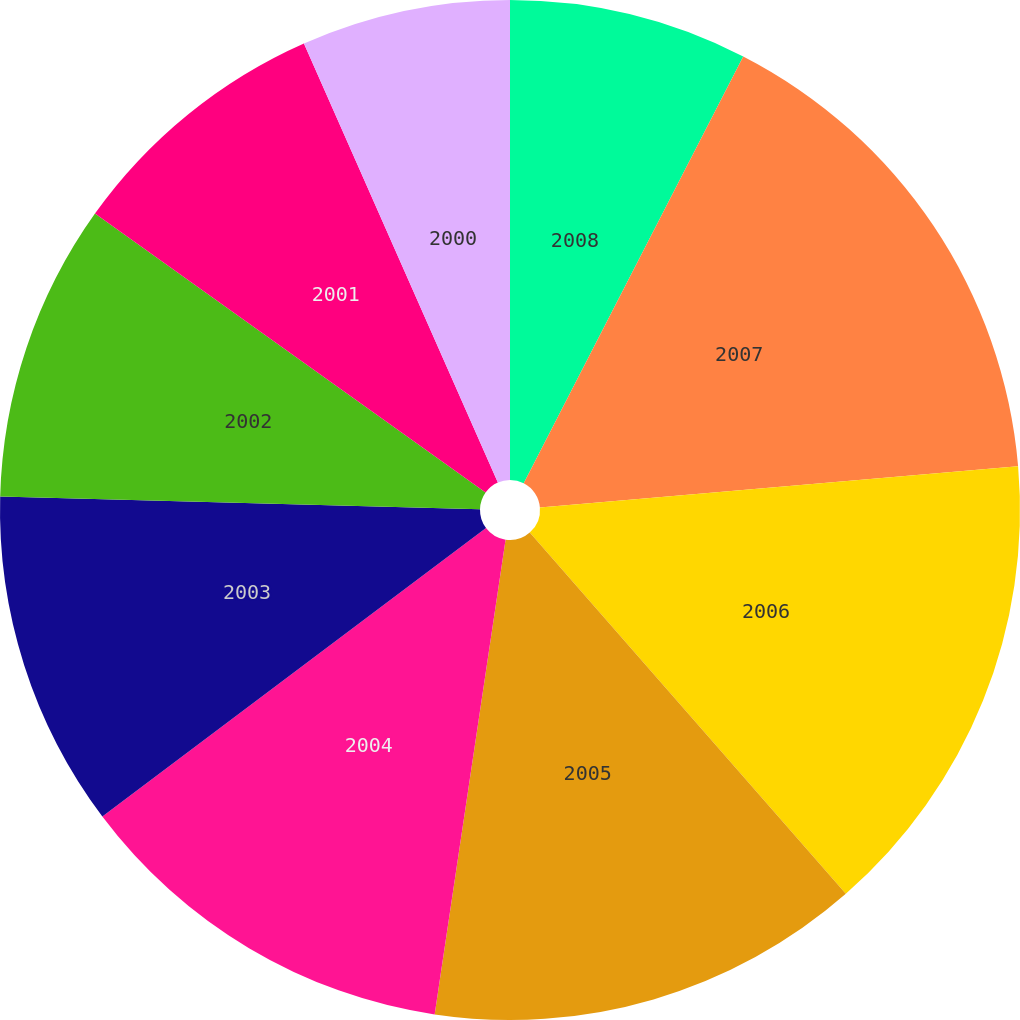Convert chart. <chart><loc_0><loc_0><loc_500><loc_500><pie_chart><fcel>2008<fcel>2007<fcel>2006<fcel>2005<fcel>2004<fcel>2003<fcel>2002<fcel>2001<fcel>2000<nl><fcel>7.56%<fcel>16.07%<fcel>14.93%<fcel>13.8%<fcel>12.38%<fcel>10.68%<fcel>9.45%<fcel>8.51%<fcel>6.62%<nl></chart> 